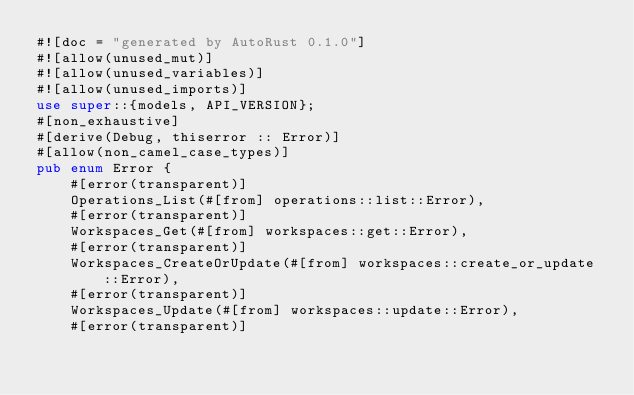<code> <loc_0><loc_0><loc_500><loc_500><_Rust_>#![doc = "generated by AutoRust 0.1.0"]
#![allow(unused_mut)]
#![allow(unused_variables)]
#![allow(unused_imports)]
use super::{models, API_VERSION};
#[non_exhaustive]
#[derive(Debug, thiserror :: Error)]
#[allow(non_camel_case_types)]
pub enum Error {
    #[error(transparent)]
    Operations_List(#[from] operations::list::Error),
    #[error(transparent)]
    Workspaces_Get(#[from] workspaces::get::Error),
    #[error(transparent)]
    Workspaces_CreateOrUpdate(#[from] workspaces::create_or_update::Error),
    #[error(transparent)]
    Workspaces_Update(#[from] workspaces::update::Error),
    #[error(transparent)]</code> 